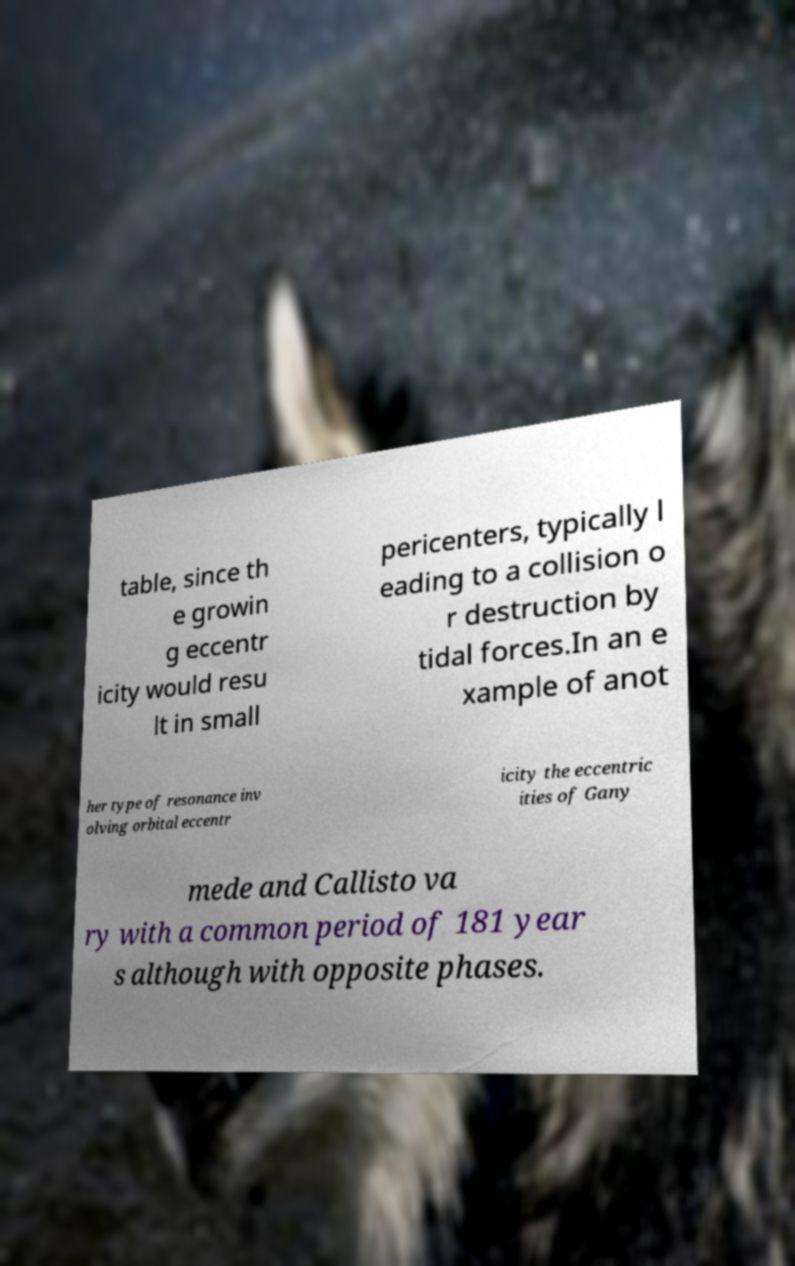Could you assist in decoding the text presented in this image and type it out clearly? table, since th e growin g eccentr icity would resu lt in small pericenters, typically l eading to a collision o r destruction by tidal forces.In an e xample of anot her type of resonance inv olving orbital eccentr icity the eccentric ities of Gany mede and Callisto va ry with a common period of 181 year s although with opposite phases. 